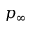<formula> <loc_0><loc_0><loc_500><loc_500>p _ { \infty }</formula> 